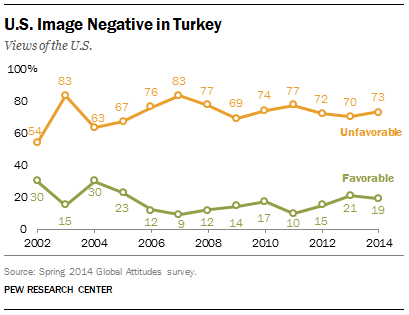Specify some key components in this picture. The median of the orange graph from 2002 to 2004 is greater than the median of the green graph from 2012 to 2014, according to the provided information. In 2014, the favorable view of the United States was measured at a percentage. 